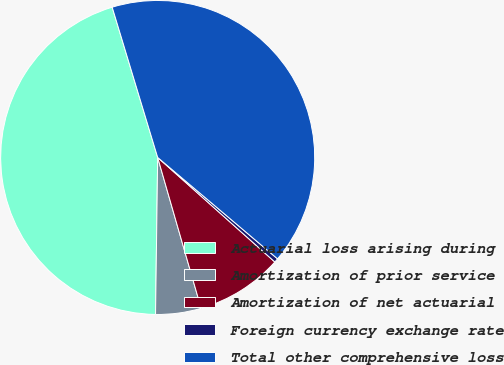Convert chart. <chart><loc_0><loc_0><loc_500><loc_500><pie_chart><fcel>Actuarial loss arising during<fcel>Amortization of prior service<fcel>Amortization of net actuarial<fcel>Foreign currency exchange rate<fcel>Total other comprehensive loss<nl><fcel>45.1%<fcel>4.68%<fcel>8.94%<fcel>0.42%<fcel>40.85%<nl></chart> 